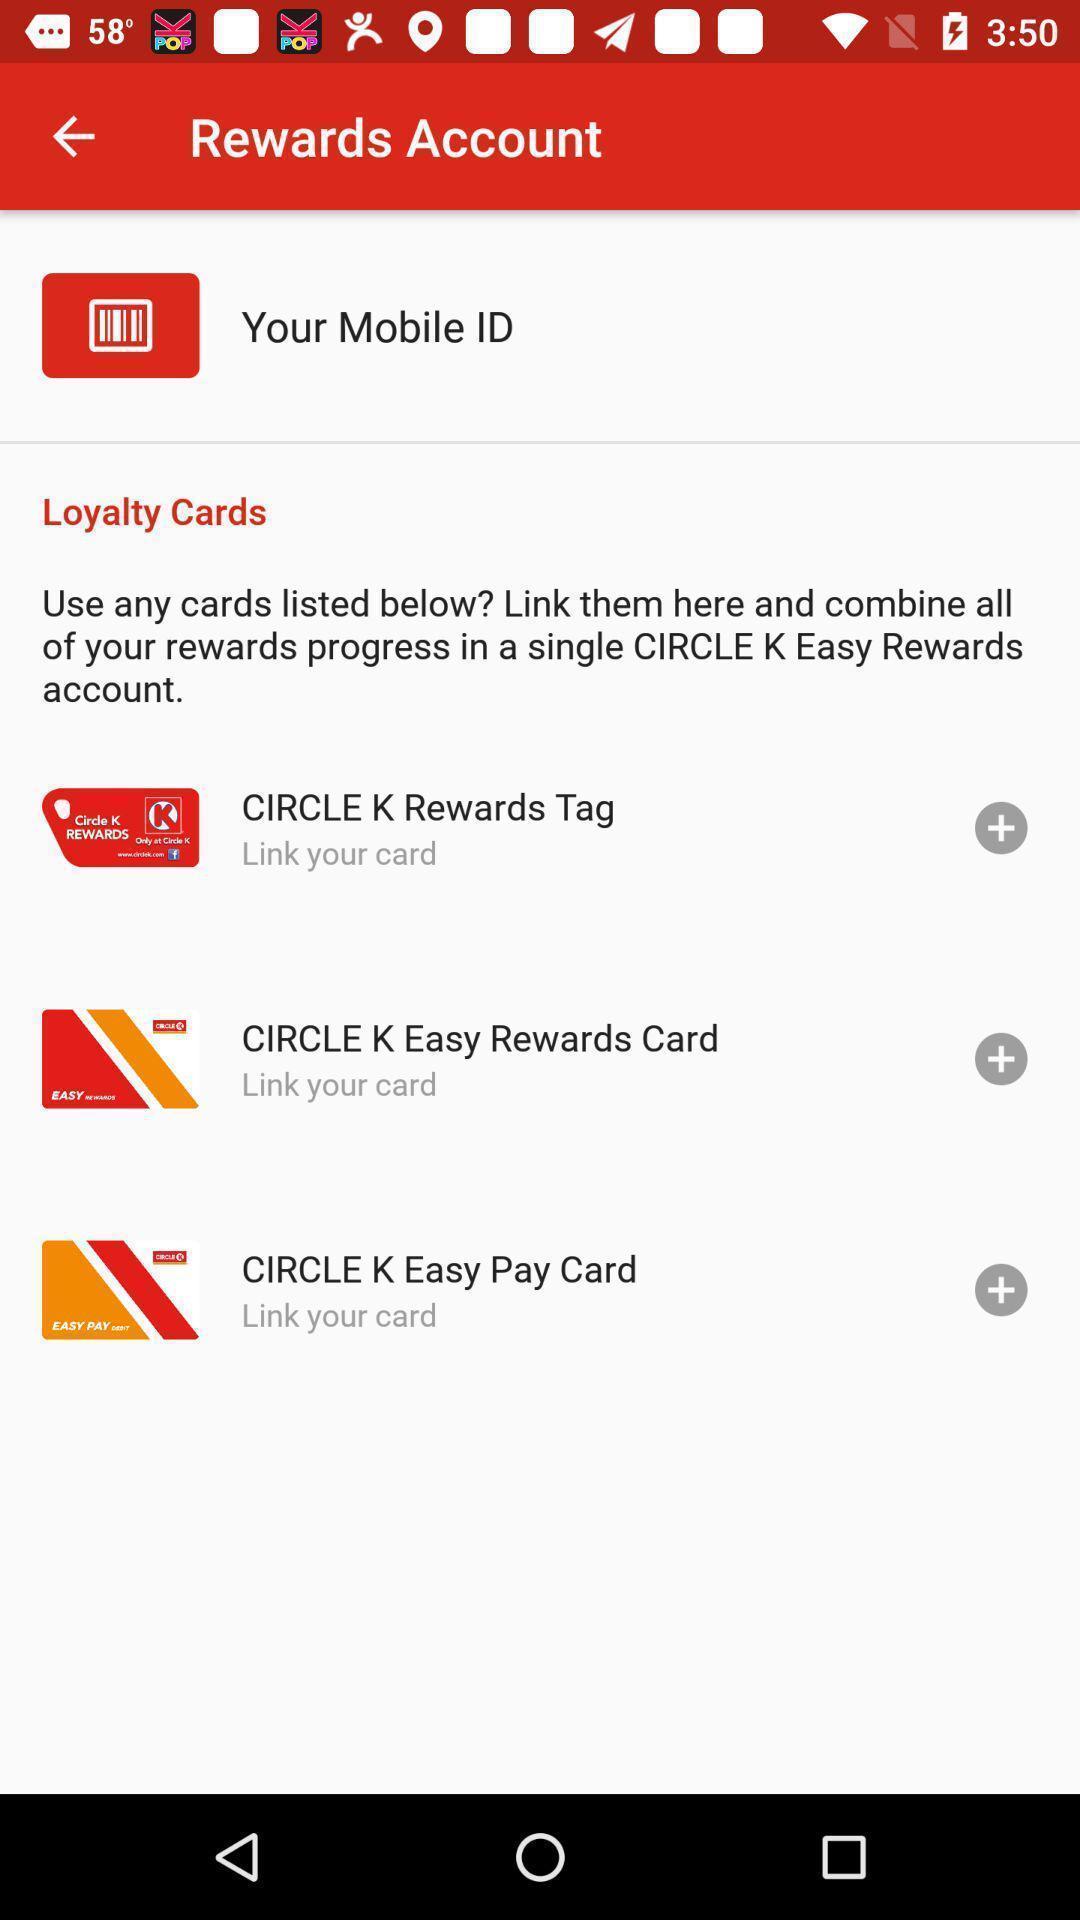Tell me what you see in this picture. Page showing loyalty cards. 